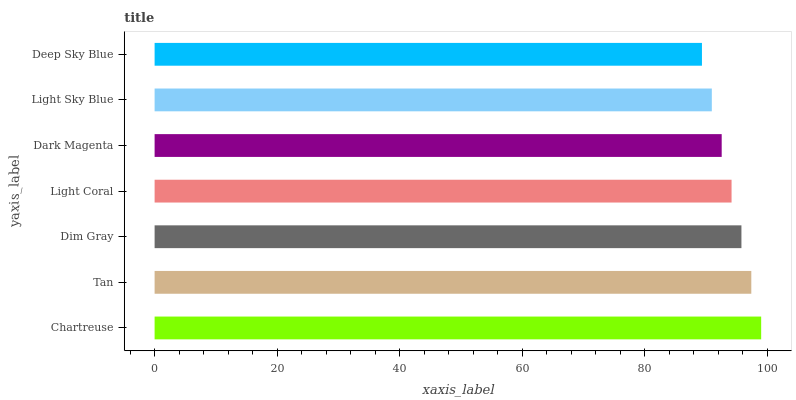Is Deep Sky Blue the minimum?
Answer yes or no. Yes. Is Chartreuse the maximum?
Answer yes or no. Yes. Is Tan the minimum?
Answer yes or no. No. Is Tan the maximum?
Answer yes or no. No. Is Chartreuse greater than Tan?
Answer yes or no. Yes. Is Tan less than Chartreuse?
Answer yes or no. Yes. Is Tan greater than Chartreuse?
Answer yes or no. No. Is Chartreuse less than Tan?
Answer yes or no. No. Is Light Coral the high median?
Answer yes or no. Yes. Is Light Coral the low median?
Answer yes or no. Yes. Is Tan the high median?
Answer yes or no. No. Is Dim Gray the low median?
Answer yes or no. No. 